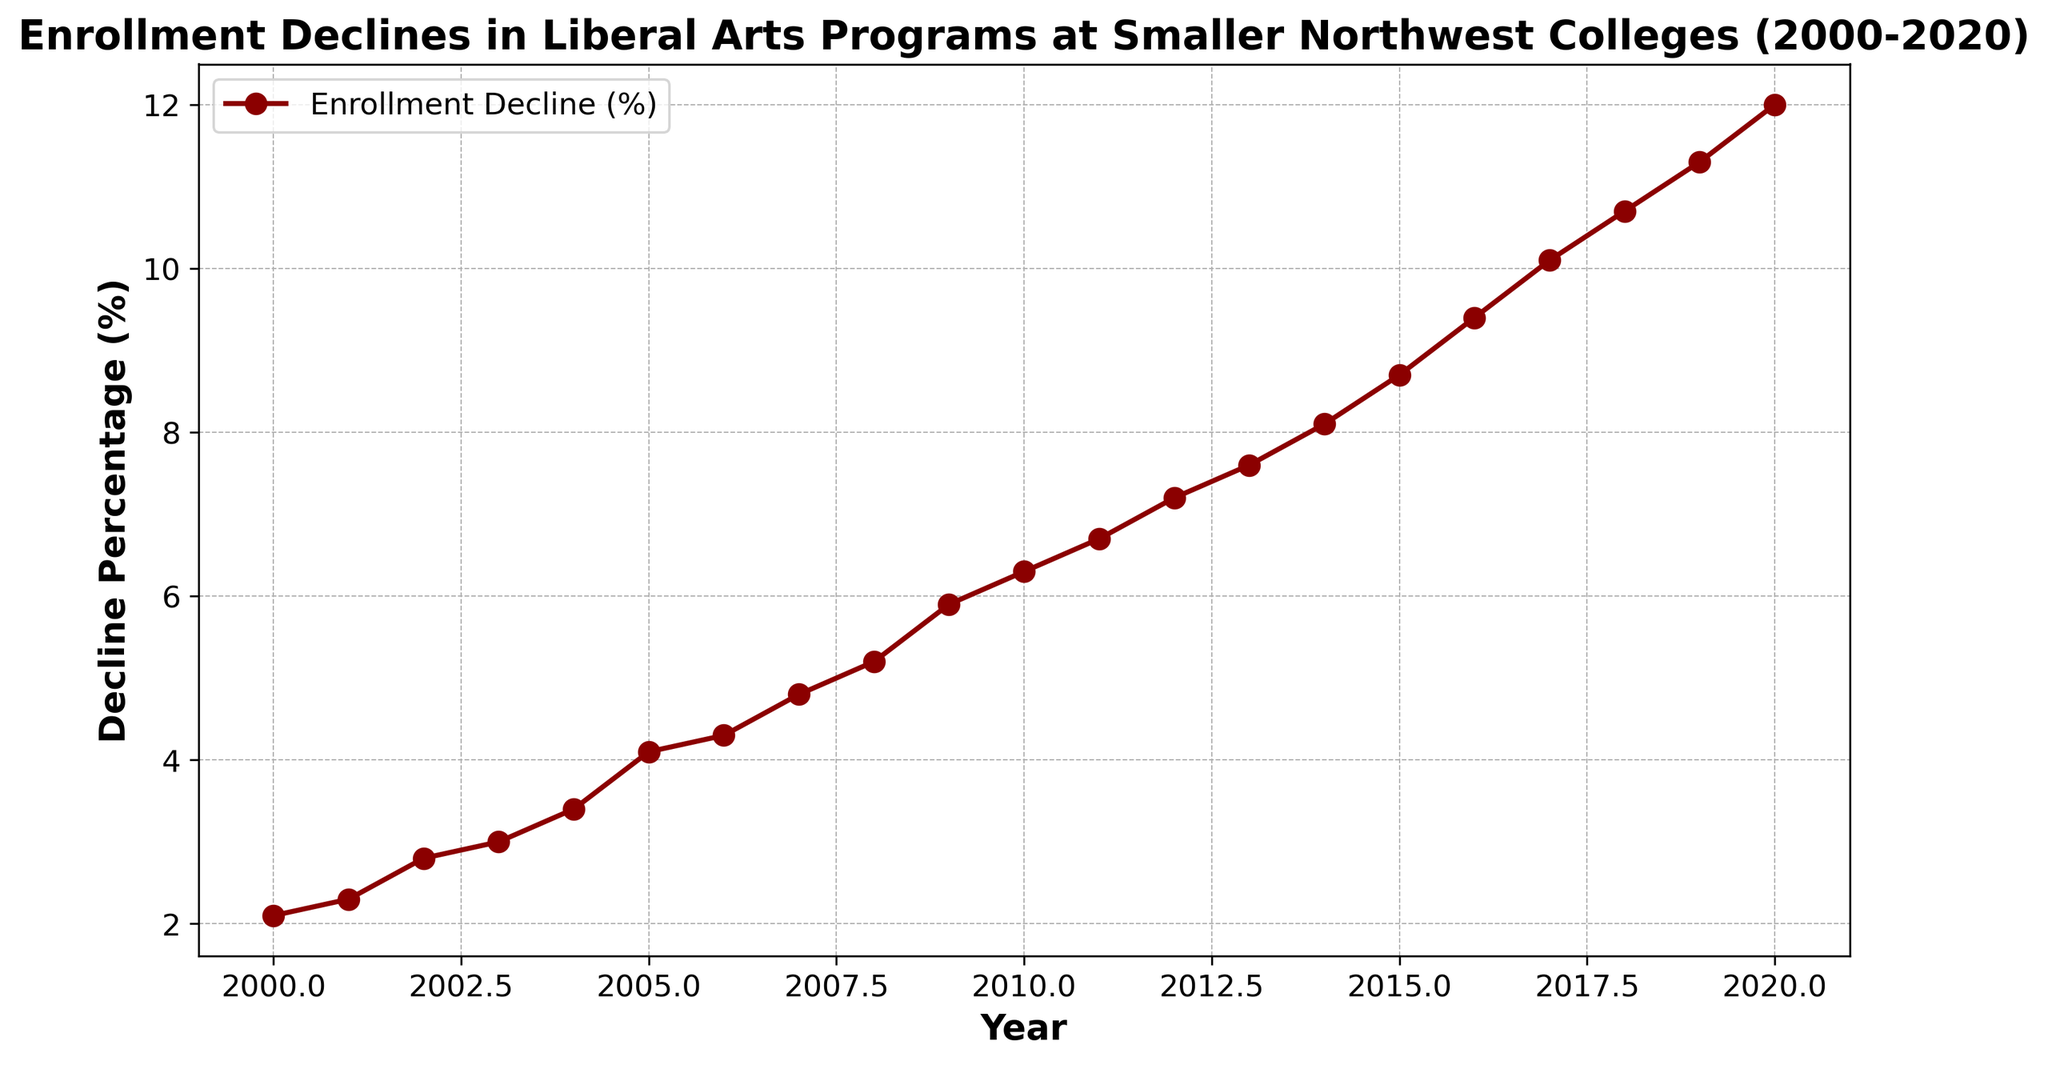What was the enrollment decline percentage in 2005? To find this, look at the point on the plot where the year is 2005. The data point above 2005 corresponds to the decline percentage for that year, which is 4.1%.
Answer: 4.1% Between which two consecutive years was the largest increase in decline percentage observed? To determine this, examine the increments between each pair of consecutive years. The largest increase is seen between 2016 and 2017, where the values jump from 9.4% to 10.1%.
Answer: 2016 and 2017 By how much did the decline percentage increase from 2000 to 2020? Subtract the decline percentage in 2000 (2.1%) from the decline percentage in 2020 (12.0%). 12.0% - 2.1% = 9.9%.
Answer: 9.9% What is the average enrollment decline percentage between 2010 and 2015? To calculate the average, sum the percentages from 2010 to 2015, then divide by the number of years. (6.3 + 6.7 + 7.2 + 7.6 + 8.1 + 8.7) / 6 = 7.27%.
Answer: 7.27% In which year did the enrollment decline percentage first exceed 5%? Identify the first year where the decline percentage is above 5% by looking at each year sequentially. The threshold is first exceeded in 2008 with a decline of 5.2%.
Answer: 2008 What is the overall trend depicted by the plot? Observing the plot from 2000 to 2020, the overall trend shows a continuous increase in the enrollment decline percentage for liberal arts programs.
Answer: Continuous increase How did the enrollment decline percentage change between 2002 and 2004? To find this, look at the decline percentages for 2002 (2.8%) and 2004 (3.4%). The change is 3.4% - 2.8% = 0.6%.
Answer: Increased by 0.6% During which decade did the enrollment decline percentage increase most sharply? Compare the increases across the decades. The decade from 2010 to 2020 has the sharpest increase, going from 6.3% to 12.0%.
Answer: 2010 to 2020 What is the median decline percentage for the entire period? List all decline percentages from 2000 to 2020 and find the middle value. With 21 values, the median is the 11th value. Sorting gives 7.2% as the median.
Answer: 7.2% 